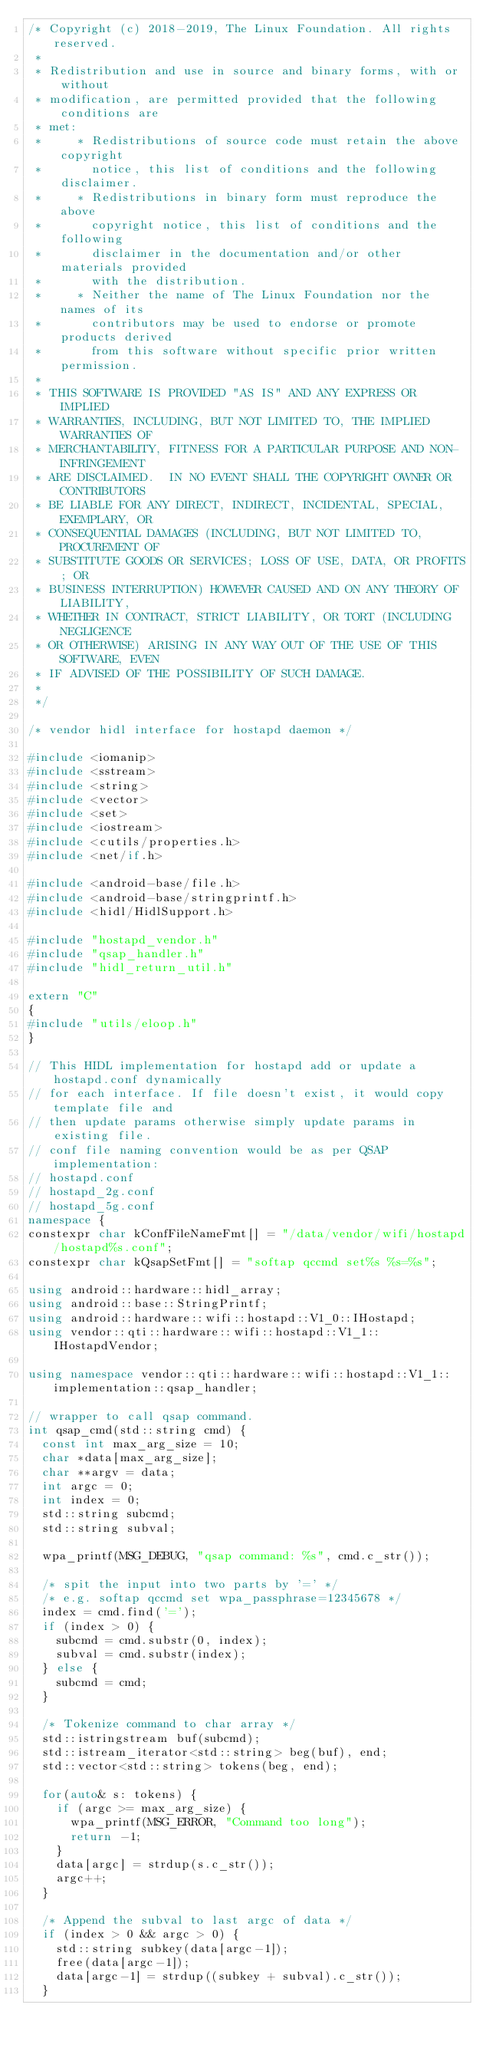<code> <loc_0><loc_0><loc_500><loc_500><_C++_>/* Copyright (c) 2018-2019, The Linux Foundation. All rights reserved.
 *
 * Redistribution and use in source and binary forms, with or without
 * modification, are permitted provided that the following conditions are
 * met:
 *     * Redistributions of source code must retain the above copyright
 *       notice, this list of conditions and the following disclaimer.
 *     * Redistributions in binary form must reproduce the above
 *       copyright notice, this list of conditions and the following
 *       disclaimer in the documentation and/or other materials provided
 *       with the distribution.
 *     * Neither the name of The Linux Foundation nor the names of its
 *       contributors may be used to endorse or promote products derived
 *       from this software without specific prior written permission.
 *
 * THIS SOFTWARE IS PROVIDED "AS IS" AND ANY EXPRESS OR IMPLIED
 * WARRANTIES, INCLUDING, BUT NOT LIMITED TO, THE IMPLIED WARRANTIES OF
 * MERCHANTABILITY, FITNESS FOR A PARTICULAR PURPOSE AND NON-INFRINGEMENT
 * ARE DISCLAIMED.  IN NO EVENT SHALL THE COPYRIGHT OWNER OR CONTRIBUTORS
 * BE LIABLE FOR ANY DIRECT, INDIRECT, INCIDENTAL, SPECIAL, EXEMPLARY, OR
 * CONSEQUENTIAL DAMAGES (INCLUDING, BUT NOT LIMITED TO, PROCUREMENT OF
 * SUBSTITUTE GOODS OR SERVICES; LOSS OF USE, DATA, OR PROFITS; OR
 * BUSINESS INTERRUPTION) HOWEVER CAUSED AND ON ANY THEORY OF LIABILITY,
 * WHETHER IN CONTRACT, STRICT LIABILITY, OR TORT (INCLUDING NEGLIGENCE
 * OR OTHERWISE) ARISING IN ANY WAY OUT OF THE USE OF THIS SOFTWARE, EVEN
 * IF ADVISED OF THE POSSIBILITY OF SUCH DAMAGE.
 *
 */

/* vendor hidl interface for hostapd daemon */

#include <iomanip>
#include <sstream>
#include <string>
#include <vector>
#include <set>
#include <iostream>
#include <cutils/properties.h>
#include <net/if.h>

#include <android-base/file.h>
#include <android-base/stringprintf.h>
#include <hidl/HidlSupport.h>

#include "hostapd_vendor.h"
#include "qsap_handler.h"
#include "hidl_return_util.h"

extern "C"
{
#include "utils/eloop.h"
}

// This HIDL implementation for hostapd add or update a hostapd.conf dynamically
// for each interface. If file doesn't exist, it would copy template file and
// then update params otherwise simply update params in existing file.
// conf file naming convention would be as per QSAP implementation:
// hostapd.conf
// hostapd_2g.conf
// hostapd_5g.conf
namespace {
constexpr char kConfFileNameFmt[] = "/data/vendor/wifi/hostapd/hostapd%s.conf";
constexpr char kQsapSetFmt[] = "softap qccmd set%s %s=%s";

using android::hardware::hidl_array;
using android::base::StringPrintf;
using android::hardware::wifi::hostapd::V1_0::IHostapd;
using vendor::qti::hardware::wifi::hostapd::V1_1::IHostapdVendor;

using namespace vendor::qti::hardware::wifi::hostapd::V1_1::implementation::qsap_handler;

// wrapper to call qsap command.
int qsap_cmd(std::string cmd) {
	const int max_arg_size = 10;
	char *data[max_arg_size];
	char **argv = data;
	int argc = 0;
	int index = 0;
	std::string subcmd;
	std::string subval;

	wpa_printf(MSG_DEBUG, "qsap command: %s", cmd.c_str());

	/* spit the input into two parts by '=' */
	/* e.g. softap qccmd set wpa_passphrase=12345678 */
	index = cmd.find('=');
	if (index > 0) {
		subcmd = cmd.substr(0, index);
		subval = cmd.substr(index);
	} else {
		subcmd = cmd;
	}

	/* Tokenize command to char array */
	std::istringstream buf(subcmd);
	std::istream_iterator<std::string> beg(buf), end;
	std::vector<std::string> tokens(beg, end);

	for(auto& s: tokens) {
		if (argc >= max_arg_size) {
			wpa_printf(MSG_ERROR, "Command too long");
			return -1;
		}
		data[argc] = strdup(s.c_str());
		argc++;
	}

	/* Append the subval to last argc of data */
	if (index > 0 && argc > 0) {
		std::string subkey(data[argc-1]);
		free(data[argc-1]);
		data[argc-1] = strdup((subkey + subval).c_str());
	}
</code> 